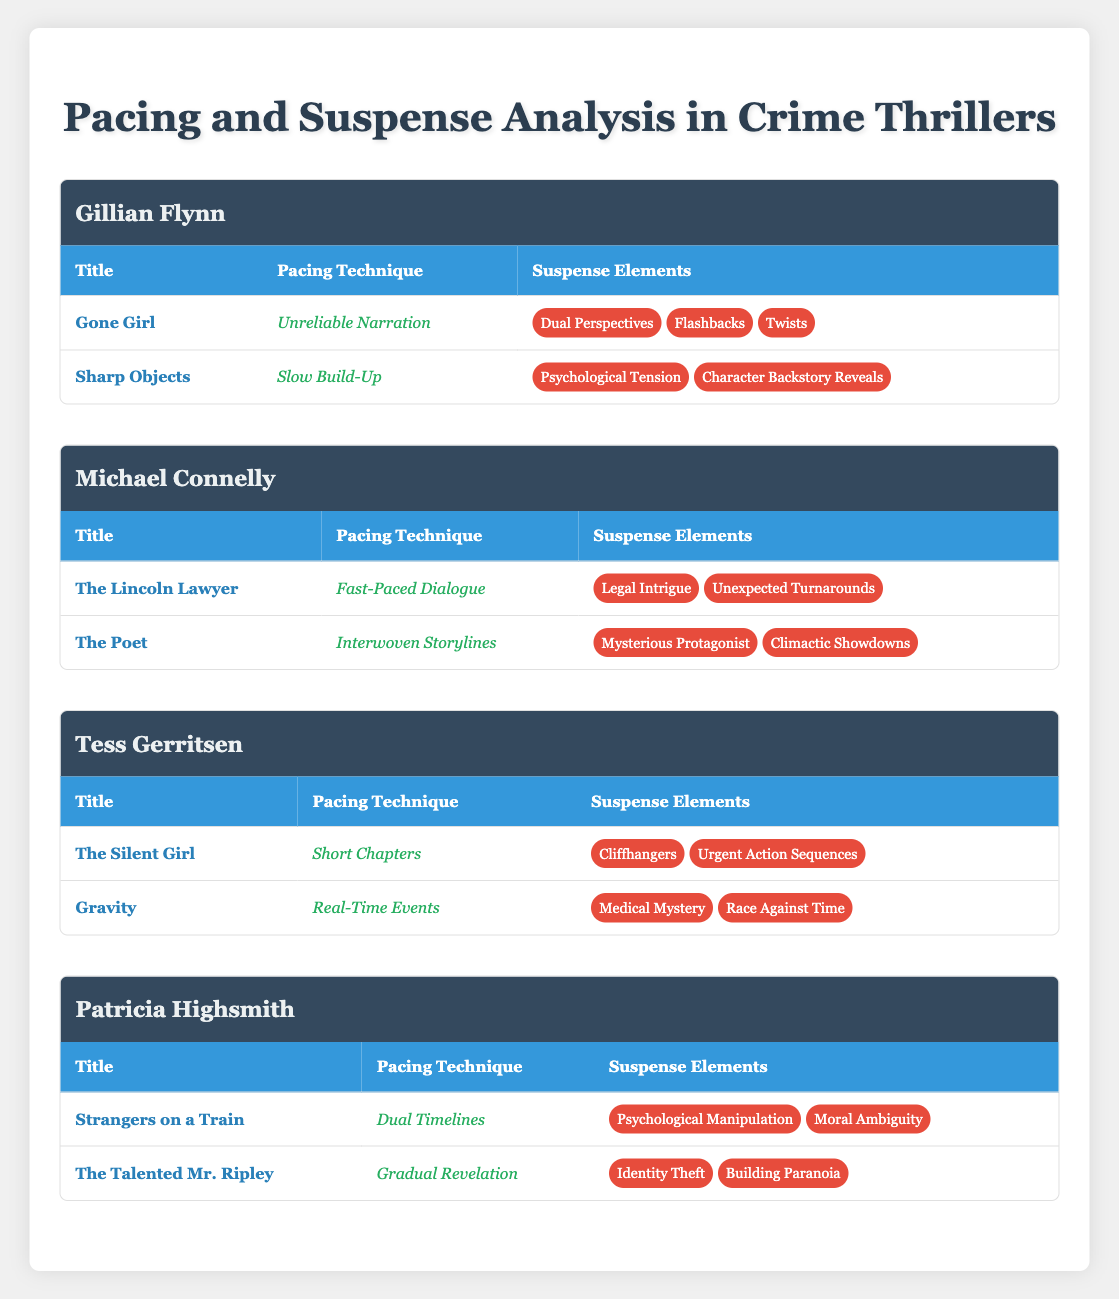What is the pacing technique used in "Gone Girl"? The pacing technique for "Gone Girl" is listed directly in the table under the author Gillian Flynn. It states "Unreliable Narration."
Answer: Unreliable Narration Which author employs Short Chapters as a pacing technique? According to the table, Tess Gerritsen uses Short Chapters for her book "The Silent Girl" listed under her name.
Answer: Tess Gerritsen How many books did Patricia Highsmith write that are listed in the table? The table shows that Patricia Highsmith has two books listed: "Strangers on a Train" and "The Talented Mr. Ripley." Thus, she wrote two books.
Answer: 2 Do both of Gillian Flynn's books utilize suspense elements related to psychological tension? In the table, "Gone Girl" has suspense elements including Dual Perspectives, Flashbacks, and Twists, while "Sharp Objects" features Psychological Tension and Character Backstory Reveals. Since only one book contains Psychological Tension, the answer is no.
Answer: No Which specific pacing technique is unique to Michael Connelly's "The Lincoln Lawyer"? From the table, "The Lincoln Lawyer" uses the pacing technique "Fast-Paced Dialogue." This is unique to this book among the ones listed under Michael Connelly.
Answer: Fast-Paced Dialogue If we consider all the suspense elements listed under Tess Gerritsen's books, how many unique suspense elements are there? Tess Gerritsen's books include "The Silent Girl" with Cliffhangers and Urgent Action Sequences, and "Gravity" with Medical Mystery and Race Against Time. This results in a total of four unique suspense elements (Cliffhangers, Urgent Action Sequences, Medical Mystery, Race Against Time).
Answer: 4 Is "Interwoven Storylines" a pacing technique used in any of the books listed by Patricia Highsmith? Looking through the table, "Interwoven Storylines" appears only in Michael Connelly's book "The Poet," not in any of Patricia Highsmith's books. Therefore, the answer is no.
Answer: No Which author's books have suspense elements focused on identity theft? The table indicates that the suspense element of Identity Theft appears in "The Talented Mr. Ripley," which is authored by Patricia Highsmith. Therefore, she is the author in question.
Answer: Patricia Highsmith What is the average number of suspense elements per book for authors who have two listed books? Authors such as Tess Gerritsen and Patricia Highsmith each have two books, with a total of 3 suspense elements for Tess (2 unique for "The Silent Girl" and 2 for "Gravity") and 2 unique for Patricia ("Strangers on a Train" and "The Talented Mr. Ripley"). The average is calculated by adding the total elements (4) and dividing by the number of books (4), resulting in 1.
Answer: 1 